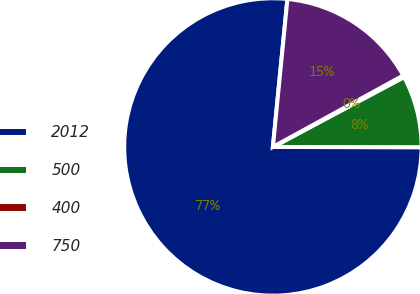Convert chart. <chart><loc_0><loc_0><loc_500><loc_500><pie_chart><fcel>2012<fcel>500<fcel>400<fcel>750<nl><fcel>76.54%<fcel>7.82%<fcel>0.19%<fcel>15.46%<nl></chart> 